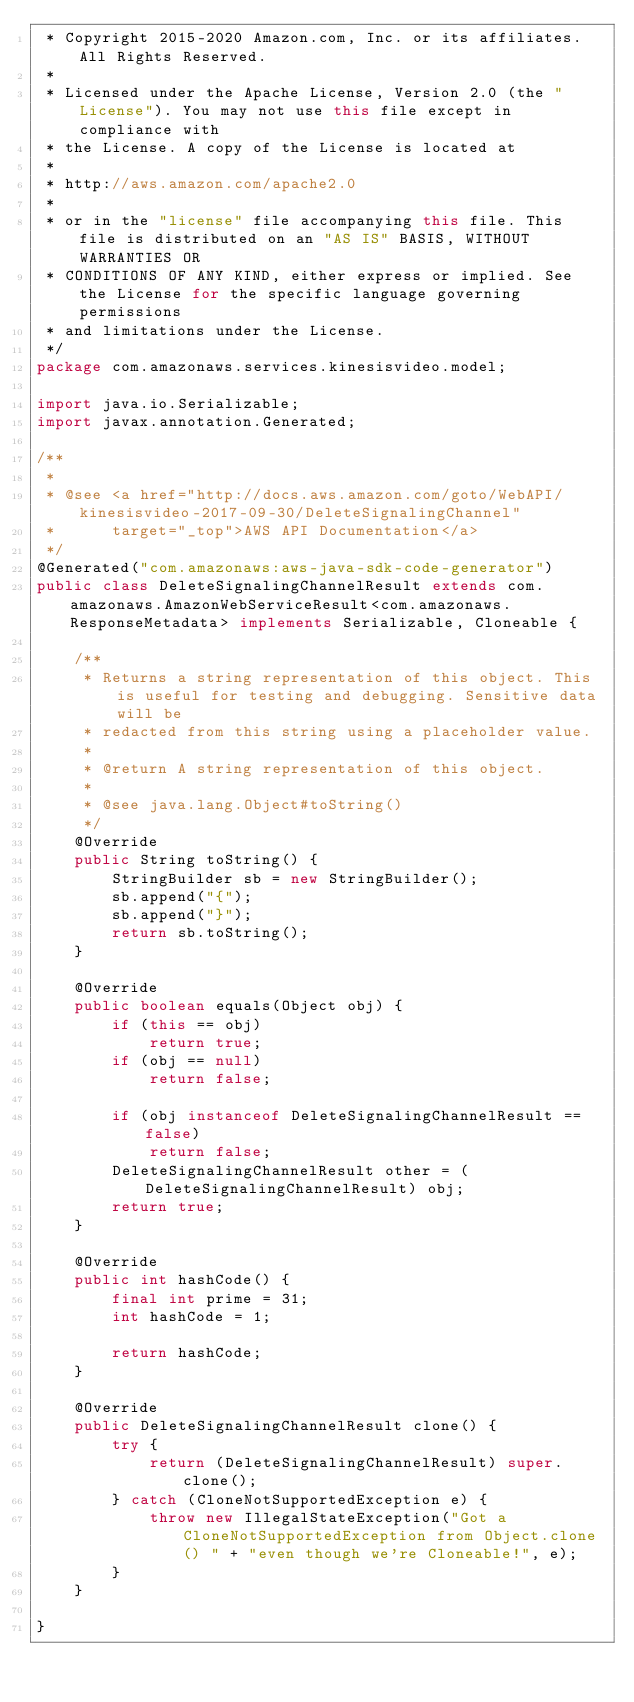Convert code to text. <code><loc_0><loc_0><loc_500><loc_500><_Java_> * Copyright 2015-2020 Amazon.com, Inc. or its affiliates. All Rights Reserved.
 * 
 * Licensed under the Apache License, Version 2.0 (the "License"). You may not use this file except in compliance with
 * the License. A copy of the License is located at
 * 
 * http://aws.amazon.com/apache2.0
 * 
 * or in the "license" file accompanying this file. This file is distributed on an "AS IS" BASIS, WITHOUT WARRANTIES OR
 * CONDITIONS OF ANY KIND, either express or implied. See the License for the specific language governing permissions
 * and limitations under the License.
 */
package com.amazonaws.services.kinesisvideo.model;

import java.io.Serializable;
import javax.annotation.Generated;

/**
 * 
 * @see <a href="http://docs.aws.amazon.com/goto/WebAPI/kinesisvideo-2017-09-30/DeleteSignalingChannel"
 *      target="_top">AWS API Documentation</a>
 */
@Generated("com.amazonaws:aws-java-sdk-code-generator")
public class DeleteSignalingChannelResult extends com.amazonaws.AmazonWebServiceResult<com.amazonaws.ResponseMetadata> implements Serializable, Cloneable {

    /**
     * Returns a string representation of this object. This is useful for testing and debugging. Sensitive data will be
     * redacted from this string using a placeholder value.
     *
     * @return A string representation of this object.
     *
     * @see java.lang.Object#toString()
     */
    @Override
    public String toString() {
        StringBuilder sb = new StringBuilder();
        sb.append("{");
        sb.append("}");
        return sb.toString();
    }

    @Override
    public boolean equals(Object obj) {
        if (this == obj)
            return true;
        if (obj == null)
            return false;

        if (obj instanceof DeleteSignalingChannelResult == false)
            return false;
        DeleteSignalingChannelResult other = (DeleteSignalingChannelResult) obj;
        return true;
    }

    @Override
    public int hashCode() {
        final int prime = 31;
        int hashCode = 1;

        return hashCode;
    }

    @Override
    public DeleteSignalingChannelResult clone() {
        try {
            return (DeleteSignalingChannelResult) super.clone();
        } catch (CloneNotSupportedException e) {
            throw new IllegalStateException("Got a CloneNotSupportedException from Object.clone() " + "even though we're Cloneable!", e);
        }
    }

}
</code> 